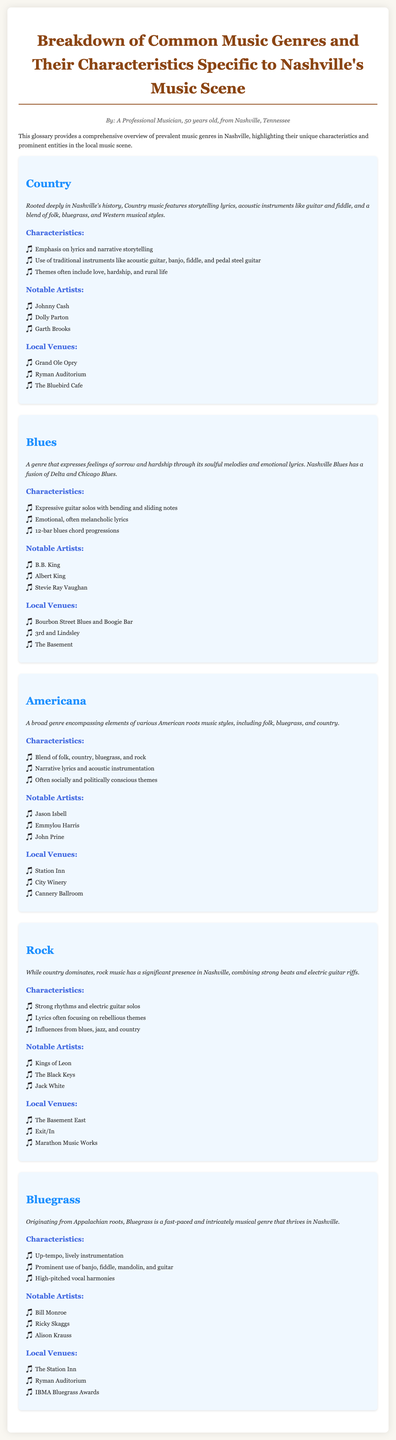What is the genre rooted deeply in Nashville's history? The document states that Country music is deeply rooted in Nashville's history, highlighting its significance in the local scene.
Answer: Country Which venue is known for hosting the Grand Ole Opry? The Grand Ole Opry is specifically listed under the local venues for the Country genre, establishing its reputation as a key venue for this type of music.
Answer: Grand Ole Opry Name a notable artist associated with Blues in Nashville. The document provides a list of notable Blues artists, and one of them is B.B. King, showcasing his importance in the genre.
Answer: B.B. King What are two characteristics of Bluegrass music? The document describes the characteristics of Bluegrass music, noting lively instrumentation and prominent instrumental use, which are critical elements of the genre.
Answer: Up-tempo, lively instrumentation; prominent use of banjo Which artist is cited as a notable figure in the Americana genre? The document lists several notable Americana artists, and Jason Isbell is one of them, indicating his relevance in this genre.
Answer: Jason Isbell What type of music incorporates elements of folk, bluegrass, and country? Americana music, as mentioned in the document, is a genre that encompasses various American roots music styles, including folk, bluegrass, and country.
Answer: Americana How many notable artists are listed for the Rock genre? The document outlines three notable artists associated with the Rock genre, which gives insight into the influential figures in this area of Nashville's music scene.
Answer: Three Which local venue is highlighted for its connection to Bluegrass music? The Station Inn is mentioned as a local venue specifically linked to Bluegrass music in Nashville, emphasizing its cultural importance.
Answer: The Station Inn 